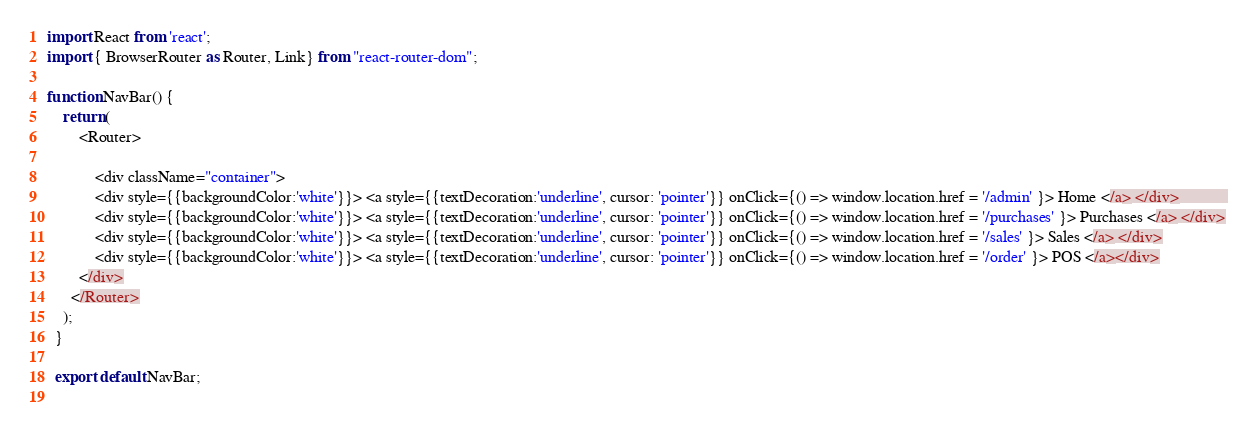Convert code to text. <code><loc_0><loc_0><loc_500><loc_500><_JavaScript_>import React from 'react';
import { BrowserRouter as Router, Link} from "react-router-dom";

function NavBar() {
    return (
        <Router>
        
            <div className="container">
            <div style={{backgroundColor:'white'}}> <a style={{textDecoration:'underline', cursor: 'pointer'}} onClick={() => window.location.href = '/admin' }> Home </a> </div>            
            <div style={{backgroundColor:'white'}}> <a style={{textDecoration:'underline', cursor: 'pointer'}} onClick={() => window.location.href = '/purchases' }> Purchases </a> </div>
            <div style={{backgroundColor:'white'}}> <a style={{textDecoration:'underline', cursor: 'pointer'}} onClick={() => window.location.href = '/sales' }> Sales </a> </div>
            <div style={{backgroundColor:'white'}}> <a style={{textDecoration:'underline', cursor: 'pointer'}} onClick={() => window.location.href = '/order' }> POS </a></div>
        </div>
      </Router>
    );
  }
  
  export default NavBar;
  </code> 